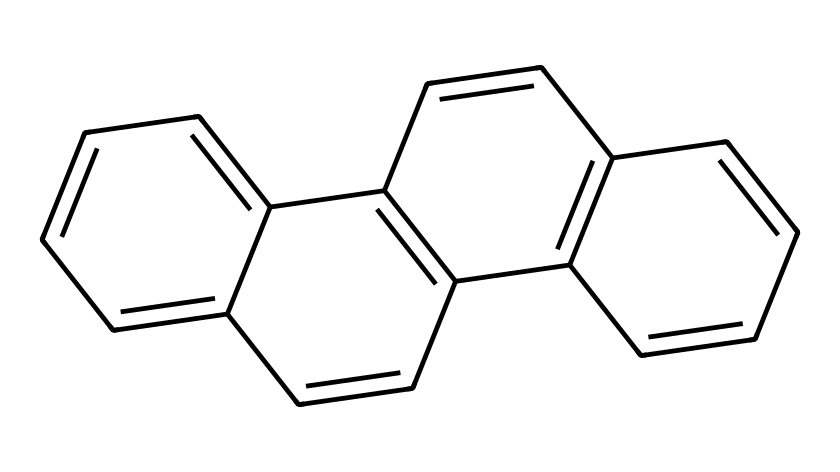What is the molecular formula of this compound? To determine the molecular formula, we can count the number of carbon and hydrogen atoms in the structure represented by the SMILES. In this specific compound, there are 18 carbon atoms and 12 hydrogen atoms giving a formula of C18H12.
Answer: C18H12 How many rings are present in this compound? By examining the structure, we can identify that this compound has a polycyclic structure where multiple interconnected ring systems exist. Counting the separate rings, we find there are four distinct rings in total.
Answer: 4 Is this compound considered aromatic? The compound has a continuous ring of p-orbitals with delocalized electrons, fulfilling Hückel's rule (4n + 2 electrons), confirming its aromatic nature.
Answer: Yes What is the general type of this compound? The compound fits the classification of polycyclic aromatic hydrocarbons (PAHs) due to the presence of multiple fused aromatic rings in its structure.
Answer: Polycyclic aromatic hydrocarbons What is the likely result of combustion of this compound in coal emissions? When combusted, polycyclic aromatic hydrocarbons like this compound can lead to the formation of various byproducts, including harmful pollutants, which can have significant environmental and health impacts.
Answer: Harmful pollutants How many hydrogen atoms are attached to each carbon? In this structure, each carbon in the rings is typically bonded such that two hydrogens are attached to carbon atoms on the edges, while carbons at the junction of rings will be bonded to either one or no hydrogens, leading to an average of 0.67 per carbon over the entire structure.
Answer: Average of 0.67 